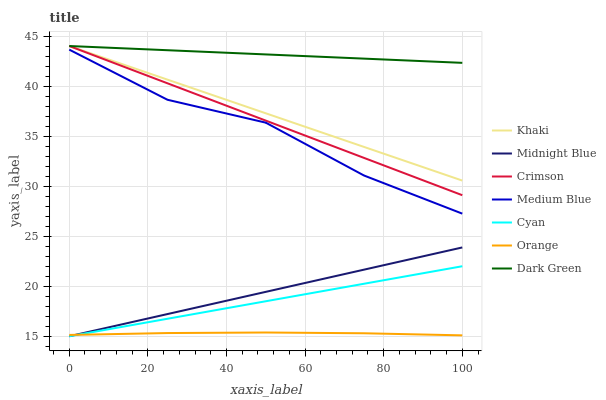Does Orange have the minimum area under the curve?
Answer yes or no. Yes. Does Dark Green have the maximum area under the curve?
Answer yes or no. Yes. Does Midnight Blue have the minimum area under the curve?
Answer yes or no. No. Does Midnight Blue have the maximum area under the curve?
Answer yes or no. No. Is Khaki the smoothest?
Answer yes or no. Yes. Is Medium Blue the roughest?
Answer yes or no. Yes. Is Midnight Blue the smoothest?
Answer yes or no. No. Is Midnight Blue the roughest?
Answer yes or no. No. Does Midnight Blue have the lowest value?
Answer yes or no. Yes. Does Medium Blue have the lowest value?
Answer yes or no. No. Does Dark Green have the highest value?
Answer yes or no. Yes. Does Midnight Blue have the highest value?
Answer yes or no. No. Is Medium Blue less than Dark Green?
Answer yes or no. Yes. Is Khaki greater than Cyan?
Answer yes or no. Yes. Does Khaki intersect Crimson?
Answer yes or no. Yes. Is Khaki less than Crimson?
Answer yes or no. No. Is Khaki greater than Crimson?
Answer yes or no. No. Does Medium Blue intersect Dark Green?
Answer yes or no. No. 